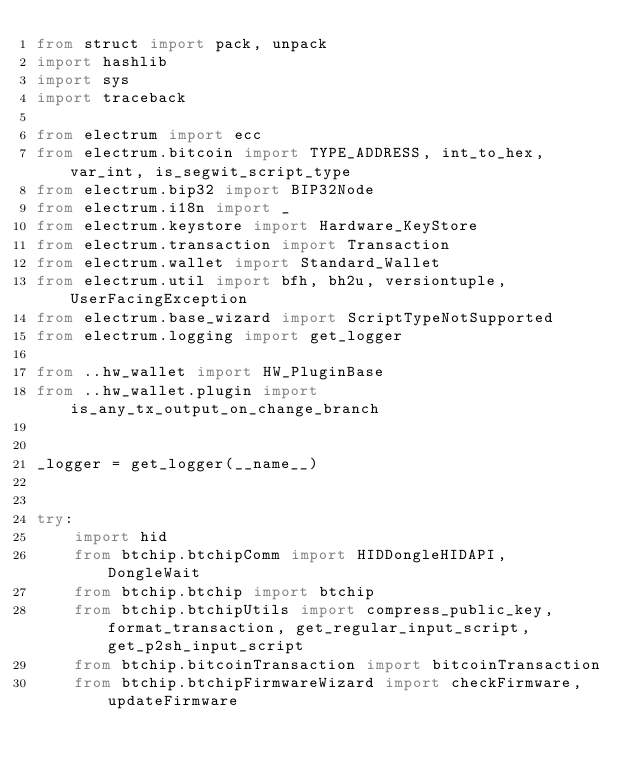Convert code to text. <code><loc_0><loc_0><loc_500><loc_500><_Python_>from struct import pack, unpack
import hashlib
import sys
import traceback

from electrum import ecc
from electrum.bitcoin import TYPE_ADDRESS, int_to_hex, var_int, is_segwit_script_type
from electrum.bip32 import BIP32Node
from electrum.i18n import _
from electrum.keystore import Hardware_KeyStore
from electrum.transaction import Transaction
from electrum.wallet import Standard_Wallet
from electrum.util import bfh, bh2u, versiontuple, UserFacingException
from electrum.base_wizard import ScriptTypeNotSupported
from electrum.logging import get_logger

from ..hw_wallet import HW_PluginBase
from ..hw_wallet.plugin import is_any_tx_output_on_change_branch


_logger = get_logger(__name__)


try:
    import hid
    from btchip.btchipComm import HIDDongleHIDAPI, DongleWait
    from btchip.btchip import btchip
    from btchip.btchipUtils import compress_public_key,format_transaction, get_regular_input_script, get_p2sh_input_script
    from btchip.bitcoinTransaction import bitcoinTransaction
    from btchip.btchipFirmwareWizard import checkFirmware, updateFirmware</code> 